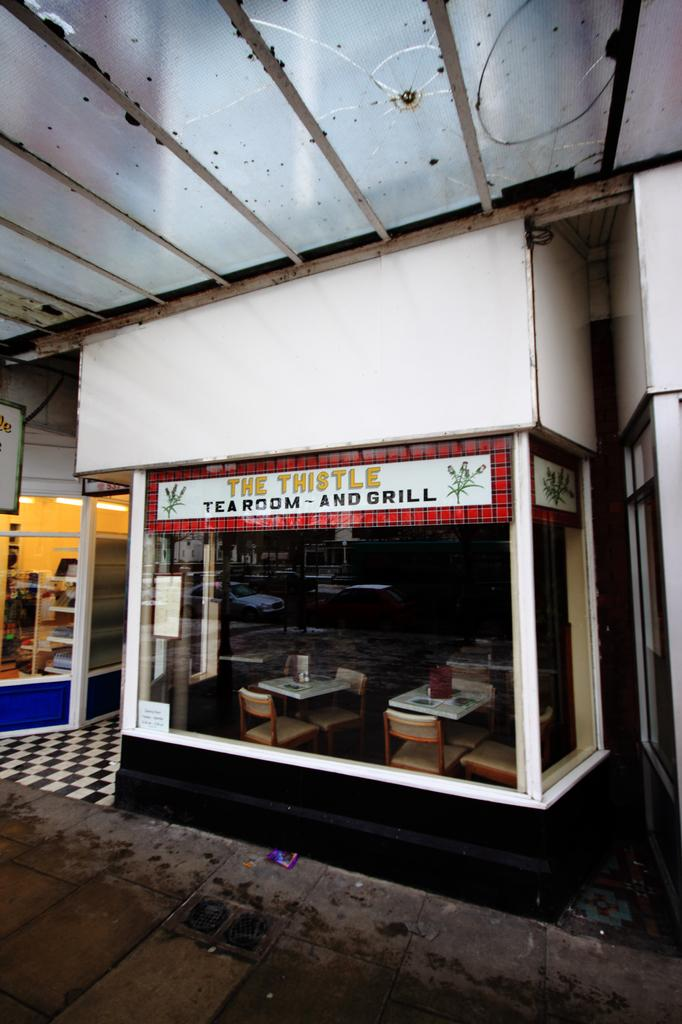What type of establishment can be seen in the image? There are stores in the image. What furniture is present inside the stores? There are chairs and tables inside the stores. What might be placed on the tables? There are objects on the tables. What type of windows can be seen in the image? There are glass windows in the image. What is the board used for in the image? The board's purpose is not specified, but it is present in the image. Can you tell me how many hands are visible in the image? There are no hands visible in the image. Is there a woman present in the image? The presence of a woman is not mentioned in the provided facts. 